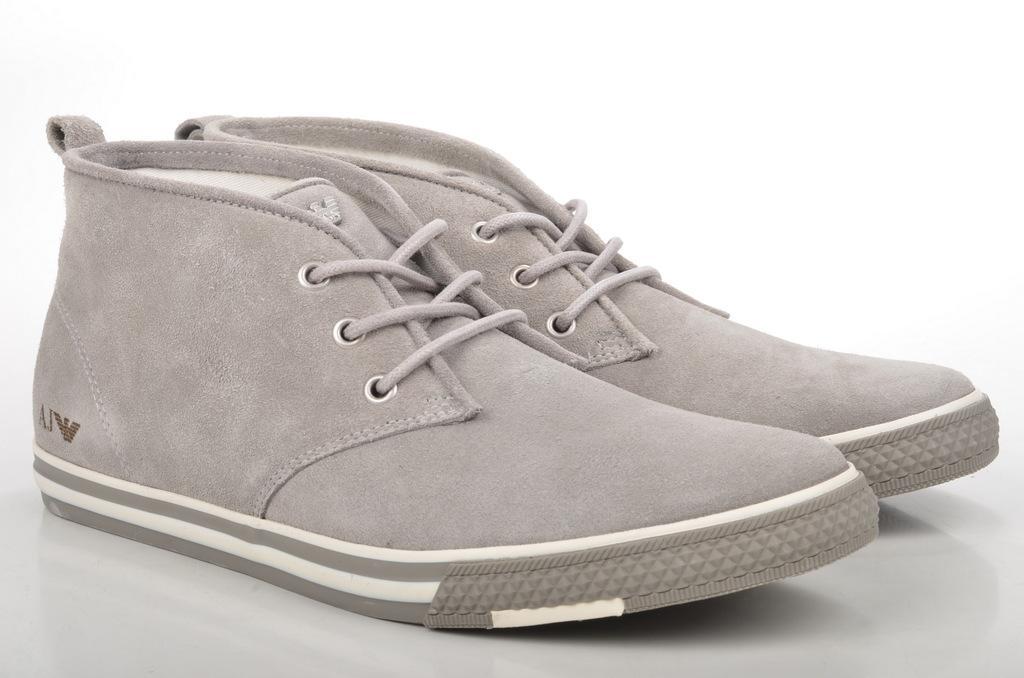Can you describe this image briefly? In this image we can see a pair of shoes and the background is white. 